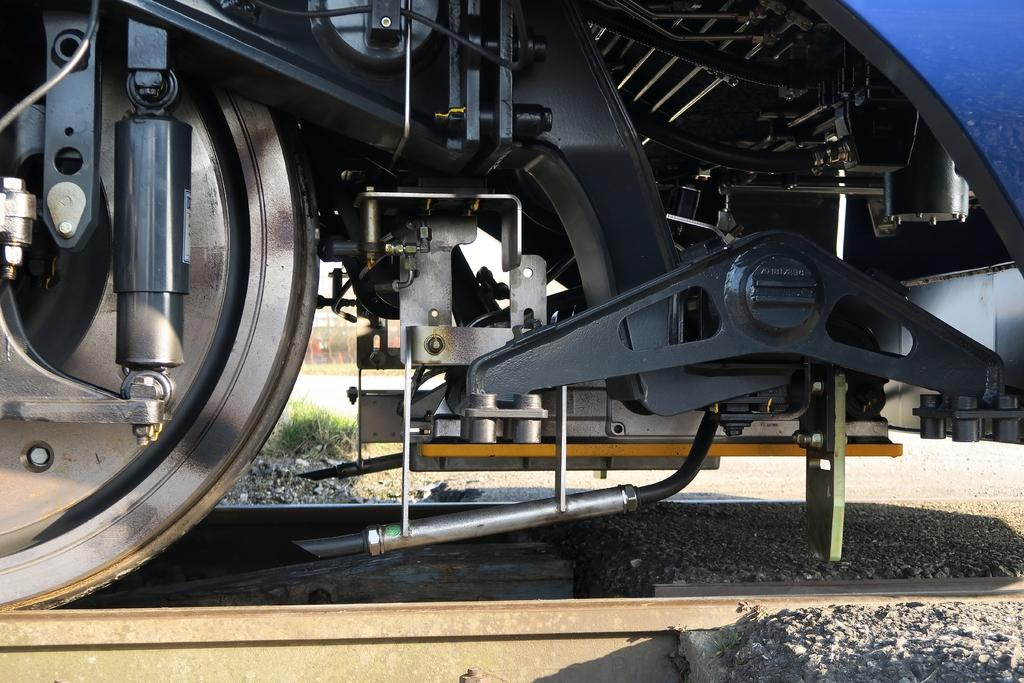What is the perspective of the image? The image is a bottom view of a train. What is the train situated on? The train is on a track. How many houses can be seen from the bottom view of the train in the image? There are no houses visible in the image, as it is a bottom view of a train on a track. What type of cars are parked near the train in the image? There are no cars present in the image, as it is a bottom view of a train on a track. 